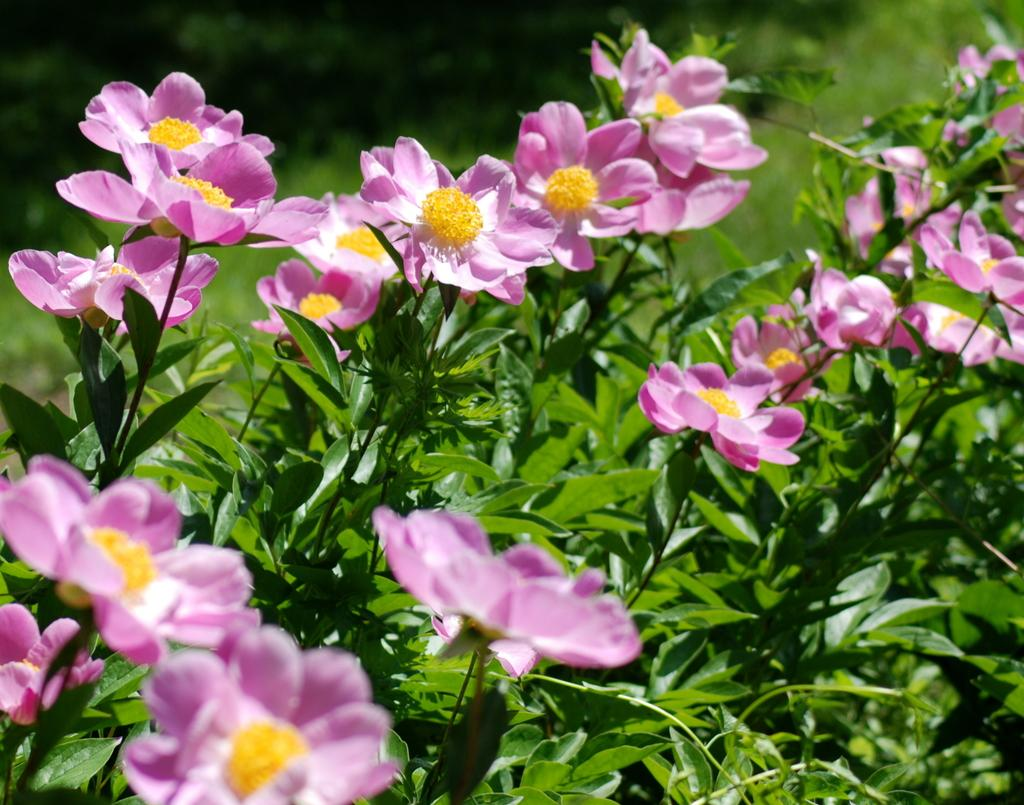What type of plants can be seen in the image? There are flower plants in the image. What color are the flowers on the plants? The flowers are pink in color. What type of metal can be seen in the image? There is no metal present in the image; it features flower plants with pink flowers. What activity is taking place in the park in the image? There is no park or activity present in the image; it only shows flower plants with pink flowers. 